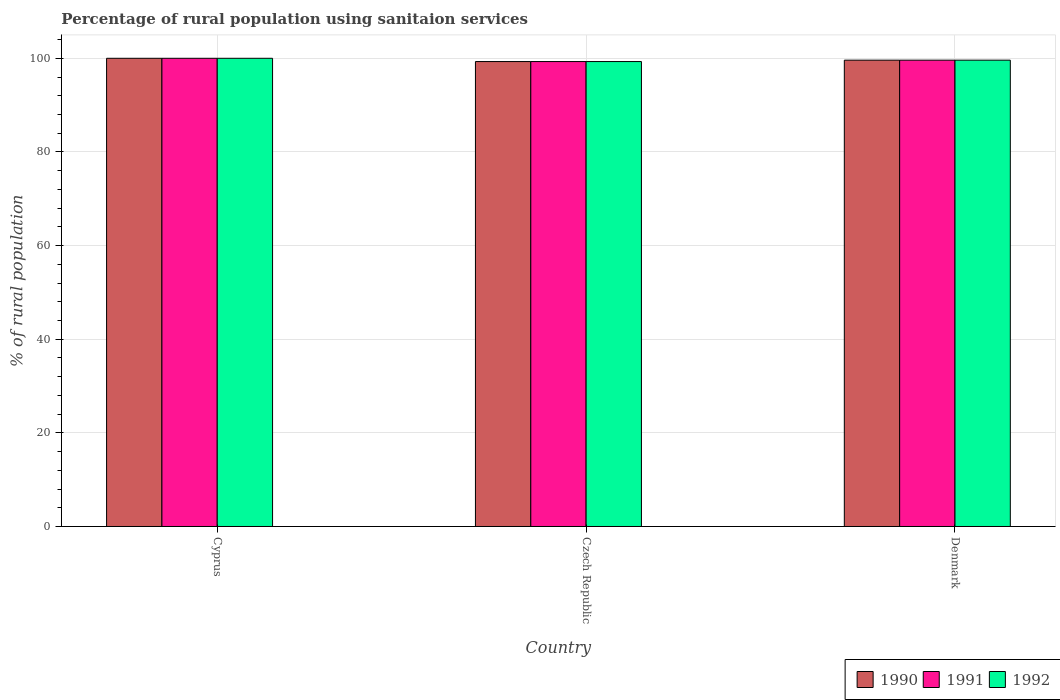How many different coloured bars are there?
Ensure brevity in your answer.  3. What is the percentage of rural population using sanitaion services in 1992 in Cyprus?
Offer a very short reply. 100. Across all countries, what is the maximum percentage of rural population using sanitaion services in 1990?
Your response must be concise. 100. Across all countries, what is the minimum percentage of rural population using sanitaion services in 1992?
Your answer should be very brief. 99.3. In which country was the percentage of rural population using sanitaion services in 1991 maximum?
Keep it short and to the point. Cyprus. In which country was the percentage of rural population using sanitaion services in 1991 minimum?
Make the answer very short. Czech Republic. What is the total percentage of rural population using sanitaion services in 1991 in the graph?
Keep it short and to the point. 298.9. What is the difference between the percentage of rural population using sanitaion services in 1992 in Czech Republic and that in Denmark?
Give a very brief answer. -0.3. What is the difference between the percentage of rural population using sanitaion services in 1992 in Czech Republic and the percentage of rural population using sanitaion services in 1990 in Denmark?
Offer a terse response. -0.3. What is the average percentage of rural population using sanitaion services in 1992 per country?
Ensure brevity in your answer.  99.63. What is the difference between the percentage of rural population using sanitaion services of/in 1992 and percentage of rural population using sanitaion services of/in 1990 in Cyprus?
Give a very brief answer. 0. What is the ratio of the percentage of rural population using sanitaion services in 1991 in Cyprus to that in Denmark?
Your response must be concise. 1. What is the difference between the highest and the second highest percentage of rural population using sanitaion services in 1992?
Provide a succinct answer. -0.3. What is the difference between the highest and the lowest percentage of rural population using sanitaion services in 1990?
Offer a very short reply. 0.7. Is the sum of the percentage of rural population using sanitaion services in 1990 in Czech Republic and Denmark greater than the maximum percentage of rural population using sanitaion services in 1992 across all countries?
Your response must be concise. Yes. What does the 3rd bar from the left in Denmark represents?
Offer a very short reply. 1992. What does the 1st bar from the right in Czech Republic represents?
Provide a short and direct response. 1992. Is it the case that in every country, the sum of the percentage of rural population using sanitaion services in 1990 and percentage of rural population using sanitaion services in 1992 is greater than the percentage of rural population using sanitaion services in 1991?
Offer a very short reply. Yes. Are all the bars in the graph horizontal?
Your response must be concise. No. Does the graph contain any zero values?
Ensure brevity in your answer.  No. Does the graph contain grids?
Your response must be concise. Yes. What is the title of the graph?
Your answer should be very brief. Percentage of rural population using sanitaion services. Does "1986" appear as one of the legend labels in the graph?
Offer a terse response. No. What is the label or title of the X-axis?
Provide a short and direct response. Country. What is the label or title of the Y-axis?
Give a very brief answer. % of rural population. What is the % of rural population of 1990 in Cyprus?
Make the answer very short. 100. What is the % of rural population of 1991 in Cyprus?
Give a very brief answer. 100. What is the % of rural population in 1990 in Czech Republic?
Make the answer very short. 99.3. What is the % of rural population in 1991 in Czech Republic?
Your response must be concise. 99.3. What is the % of rural population in 1992 in Czech Republic?
Provide a short and direct response. 99.3. What is the % of rural population of 1990 in Denmark?
Keep it short and to the point. 99.6. What is the % of rural population of 1991 in Denmark?
Provide a succinct answer. 99.6. What is the % of rural population of 1992 in Denmark?
Keep it short and to the point. 99.6. Across all countries, what is the maximum % of rural population in 1990?
Provide a short and direct response. 100. Across all countries, what is the maximum % of rural population of 1991?
Provide a short and direct response. 100. Across all countries, what is the maximum % of rural population in 1992?
Your answer should be compact. 100. Across all countries, what is the minimum % of rural population of 1990?
Your answer should be very brief. 99.3. Across all countries, what is the minimum % of rural population in 1991?
Keep it short and to the point. 99.3. Across all countries, what is the minimum % of rural population in 1992?
Offer a very short reply. 99.3. What is the total % of rural population of 1990 in the graph?
Your answer should be compact. 298.9. What is the total % of rural population of 1991 in the graph?
Your answer should be very brief. 298.9. What is the total % of rural population of 1992 in the graph?
Give a very brief answer. 298.9. What is the difference between the % of rural population of 1992 in Cyprus and that in Czech Republic?
Give a very brief answer. 0.7. What is the difference between the % of rural population in 1990 in Cyprus and that in Denmark?
Keep it short and to the point. 0.4. What is the difference between the % of rural population of 1991 in Cyprus and that in Denmark?
Offer a terse response. 0.4. What is the difference between the % of rural population in 1992 in Cyprus and that in Denmark?
Ensure brevity in your answer.  0.4. What is the difference between the % of rural population in 1990 in Czech Republic and that in Denmark?
Provide a succinct answer. -0.3. What is the difference between the % of rural population of 1991 in Czech Republic and that in Denmark?
Give a very brief answer. -0.3. What is the difference between the % of rural population in 1990 in Cyprus and the % of rural population in 1991 in Czech Republic?
Offer a very short reply. 0.7. What is the difference between the % of rural population of 1990 in Cyprus and the % of rural population of 1992 in Czech Republic?
Provide a succinct answer. 0.7. What is the difference between the % of rural population of 1990 in Cyprus and the % of rural population of 1991 in Denmark?
Keep it short and to the point. 0.4. What is the difference between the % of rural population in 1991 in Cyprus and the % of rural population in 1992 in Denmark?
Your answer should be very brief. 0.4. What is the difference between the % of rural population of 1990 in Czech Republic and the % of rural population of 1991 in Denmark?
Provide a succinct answer. -0.3. What is the difference between the % of rural population of 1990 in Czech Republic and the % of rural population of 1992 in Denmark?
Ensure brevity in your answer.  -0.3. What is the difference between the % of rural population in 1991 in Czech Republic and the % of rural population in 1992 in Denmark?
Make the answer very short. -0.3. What is the average % of rural population in 1990 per country?
Ensure brevity in your answer.  99.63. What is the average % of rural population of 1991 per country?
Offer a terse response. 99.63. What is the average % of rural population of 1992 per country?
Keep it short and to the point. 99.63. What is the difference between the % of rural population of 1990 and % of rural population of 1992 in Cyprus?
Make the answer very short. 0. What is the difference between the % of rural population in 1990 and % of rural population in 1991 in Czech Republic?
Offer a terse response. 0. What is the difference between the % of rural population of 1990 and % of rural population of 1992 in Czech Republic?
Give a very brief answer. 0. What is the difference between the % of rural population of 1990 and % of rural population of 1991 in Denmark?
Your answer should be compact. 0. What is the difference between the % of rural population of 1991 and % of rural population of 1992 in Denmark?
Your response must be concise. 0. What is the ratio of the % of rural population of 1990 in Cyprus to that in Czech Republic?
Provide a succinct answer. 1.01. What is the ratio of the % of rural population in 1992 in Cyprus to that in Czech Republic?
Provide a succinct answer. 1.01. What is the ratio of the % of rural population of 1990 in Cyprus to that in Denmark?
Ensure brevity in your answer.  1. What is the ratio of the % of rural population in 1992 in Cyprus to that in Denmark?
Offer a very short reply. 1. What is the ratio of the % of rural population in 1990 in Czech Republic to that in Denmark?
Your answer should be compact. 1. What is the ratio of the % of rural population in 1991 in Czech Republic to that in Denmark?
Give a very brief answer. 1. What is the ratio of the % of rural population in 1992 in Czech Republic to that in Denmark?
Offer a terse response. 1. What is the difference between the highest and the second highest % of rural population in 1990?
Give a very brief answer. 0.4. What is the difference between the highest and the second highest % of rural population of 1991?
Your answer should be compact. 0.4. What is the difference between the highest and the lowest % of rural population in 1990?
Make the answer very short. 0.7. What is the difference between the highest and the lowest % of rural population in 1992?
Your answer should be compact. 0.7. 